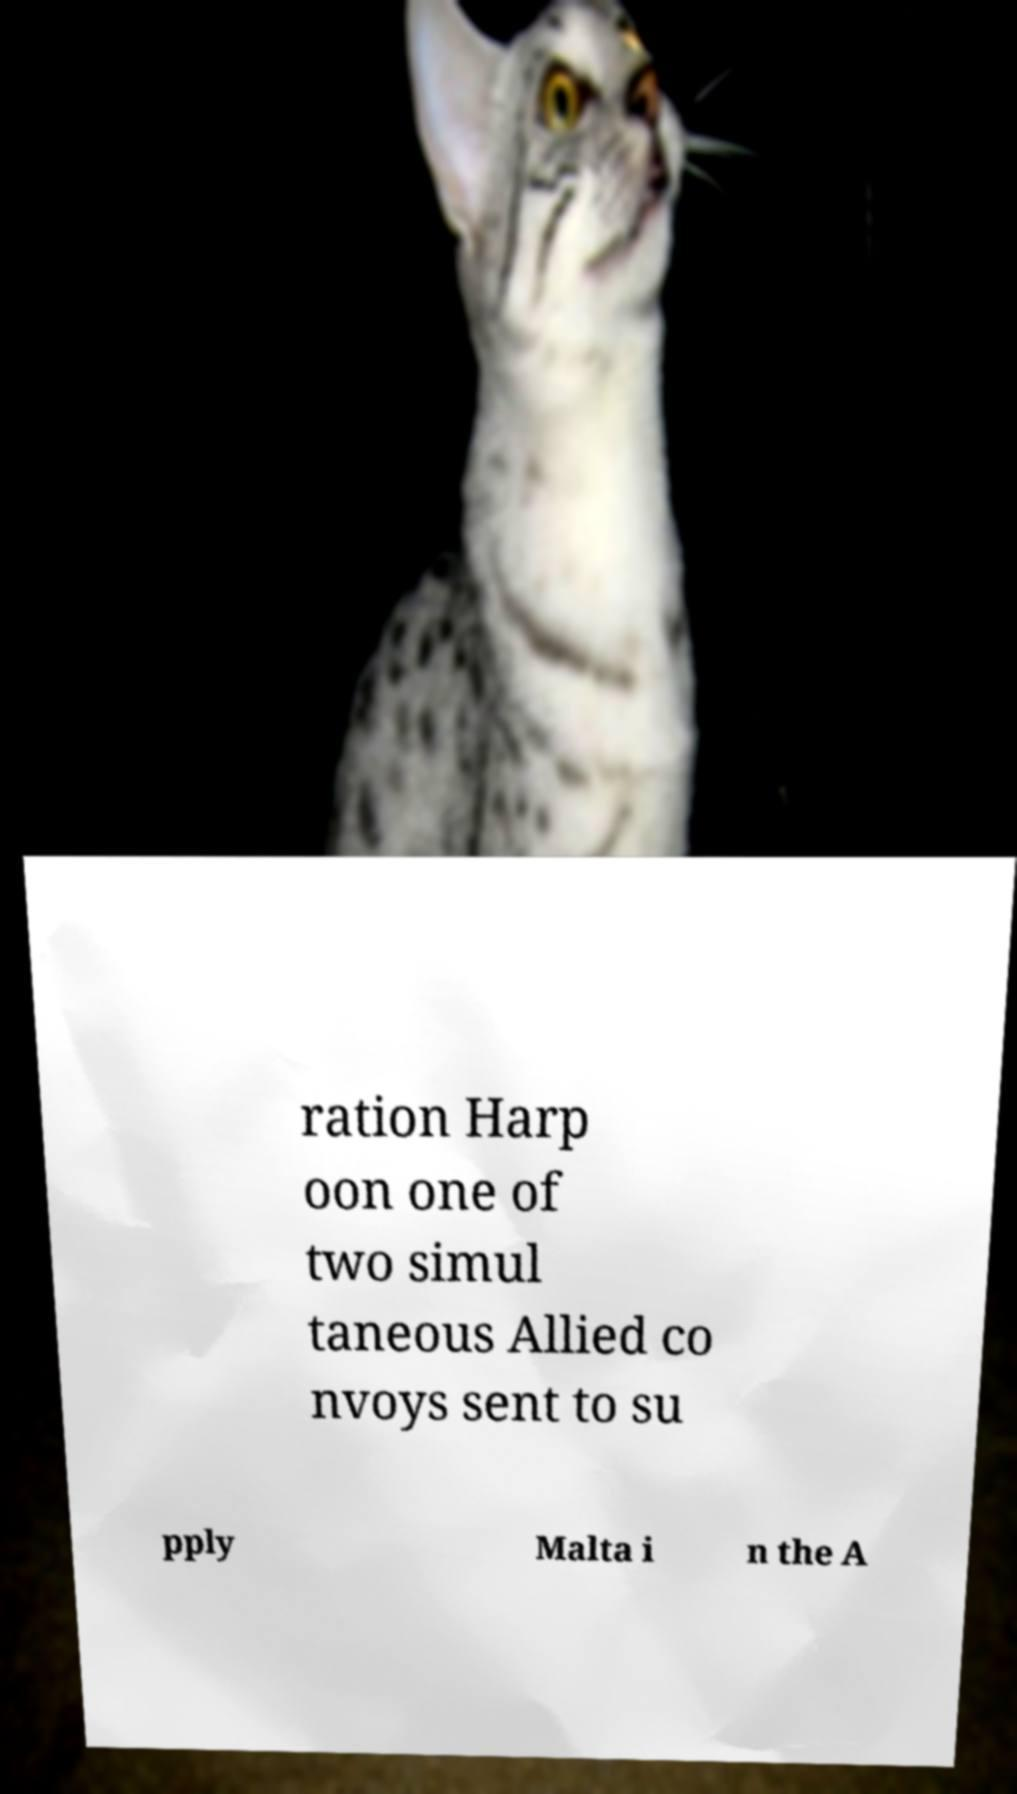Please read and relay the text visible in this image. What does it say? ration Harp oon one of two simul taneous Allied co nvoys sent to su pply Malta i n the A 